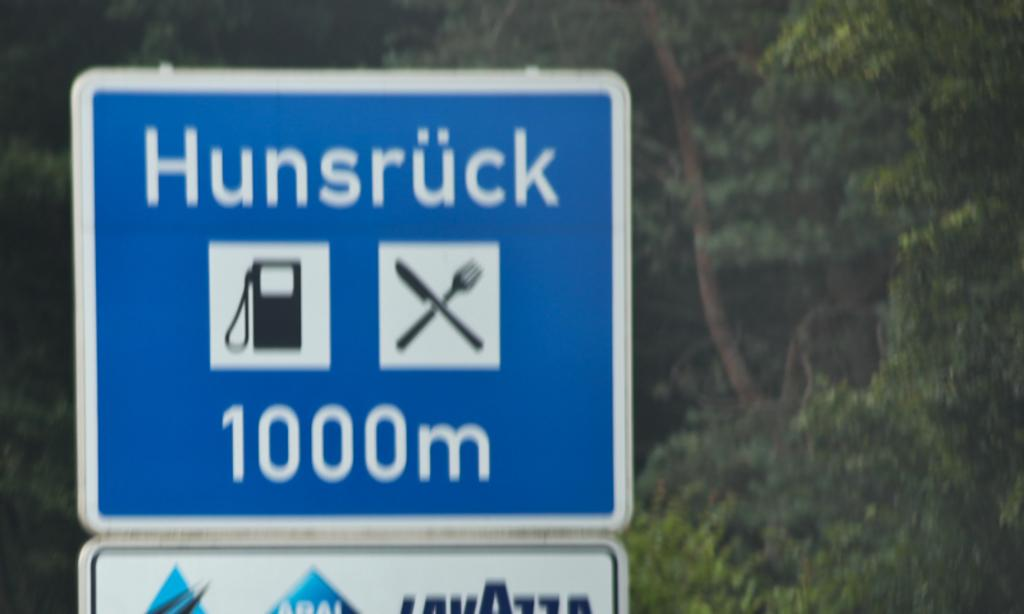<image>
Write a terse but informative summary of the picture. A sign notifies of gas in 1000 m as well as dining. 